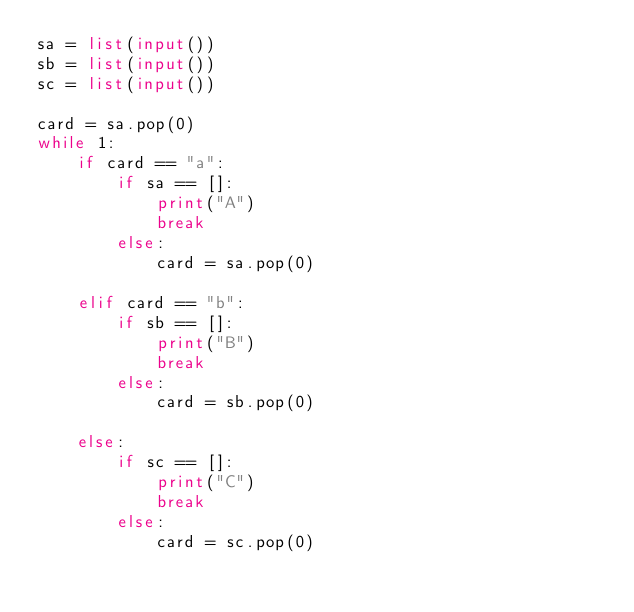<code> <loc_0><loc_0><loc_500><loc_500><_Python_>sa = list(input())
sb = list(input())
sc = list(input())

card = sa.pop(0)
while 1:
    if card == "a":
        if sa == []:
            print("A")
            break
        else:
            card = sa.pop(0)

    elif card == "b":
        if sb == []:
            print("B")
            break
        else:
            card = sb.pop(0)

    else:
        if sc == []:
            print("C")
            break
        else:
            card = sc.pop(0)</code> 